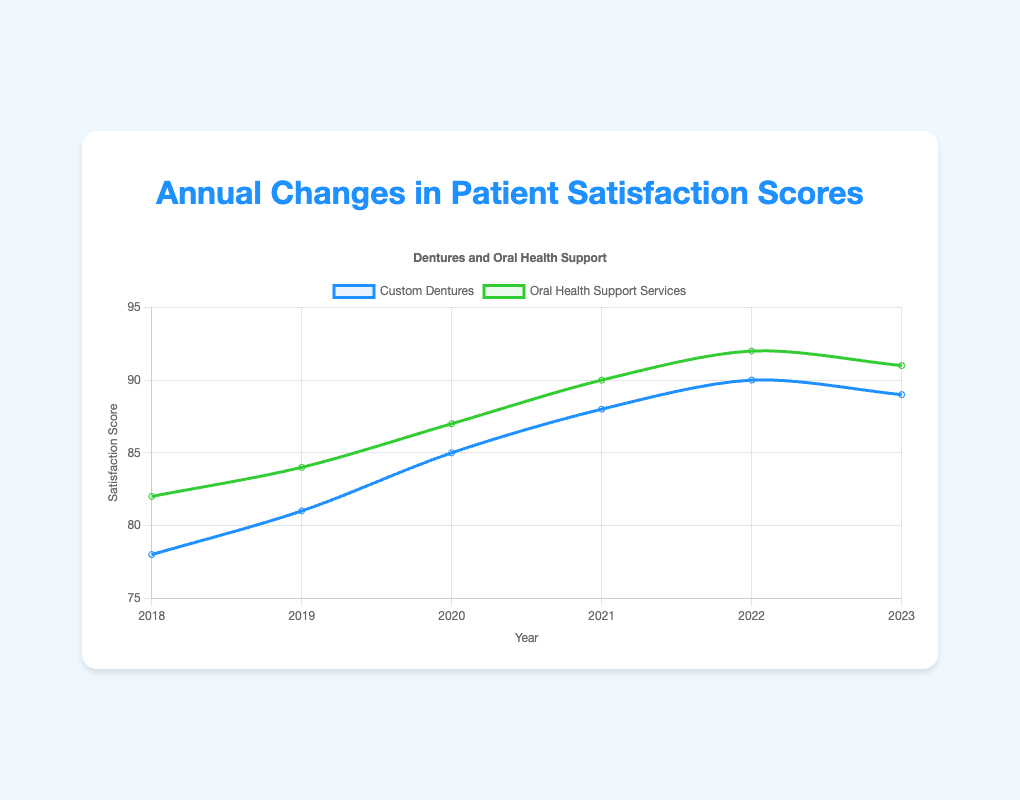What is the general trend for patient satisfaction with custom dentures from 2018 to 2023? The satisfaction scores for custom dentures started at 78 in 2018 and increased over the years, peaking at 90 in 2022 before slightly dropping to 89 in 2023. The general trend is increasing.
Answer: Increasing How does patient satisfaction with oral health support services in 2020 compare to custom dentures in 2020? In 2020, the satisfaction score for oral health support services was 87, while for custom dentures it was 85. Therefore, oral health support services had a higher satisfaction score.
Answer: Oral health support services had a higher satisfaction score What is the largest increase in satisfaction for any service between two consecutive years? The largest increase in satisfaction score for custom dentures is 4 points between 2019 and 2020 (from 81 to 85), and for oral health support services, it is also 3 points between 2019 and 2020 (from 84 to 87). So, the largest increase is 4 points for custom dentures between 2019 and 2020.
Answer: 4 points for custom dentures between 2019 and 2020 On average, how did patient satisfaction with custom dentures change year over year? To calculate the average year-over-year change, subtract the scores of consecutive years, sum them up, and divide by the number of intervals: ((81-78) + (85-81) + (88-85) + (90-88) + (89-90)) / 5 = (3 + 4 + 3 + 2 - 1) / 5 = 11/5 = 2.2. The average change is an increase of 2.2 points per year.
Answer: 2.2 points per year In which year did patient satisfaction with custom dentures peak? Patient satisfaction with custom dentures reached its highest point in the year 2022 with a score of 90.
Answer: 2022 Compare the trends for custom dentures and oral health support services between 2019 and 2023. Both custom dentures and oral health support services show an increasing trend between 2019 and 2022. However, while custom dentures' satisfaction score slightly declined from 90 to 89 in 2023, oral health support services' score declined from 92 to 91. Despite this, oral health support services consistently had higher scores.
Answer: Both increased then slightly declined, oral health support services always higher Calculate the average satisfaction score for oral health support services from 2018 to 2023. Add all the scores for the years 2018 to 2023 and divide by the number of years: (82 + 84 + 87 + 90 + 92 + 91) / 6 = 526 / 6 ≈ 87.67. The average satisfaction score for oral health support services is approximately 87.67.
Answer: 87.67 Which service had the smallest decrease in satisfaction score in 2023 compared to 2022? In 2023, the satisfaction score for custom dentures decreased by 1 point (from 90 to 89), and for oral health support services, it decreased by 1 point (from 92 to 91). Both services had the same decrease of 1 point.
Answer: Both had the same decrease What is the difference in the satisfaction scores between custom dentures and oral health support services in 2018? In 2018, the satisfaction score for custom dentures was 78, and for oral health support services, it was 82. The difference is 82 - 78 = 4.
Answer: 4 